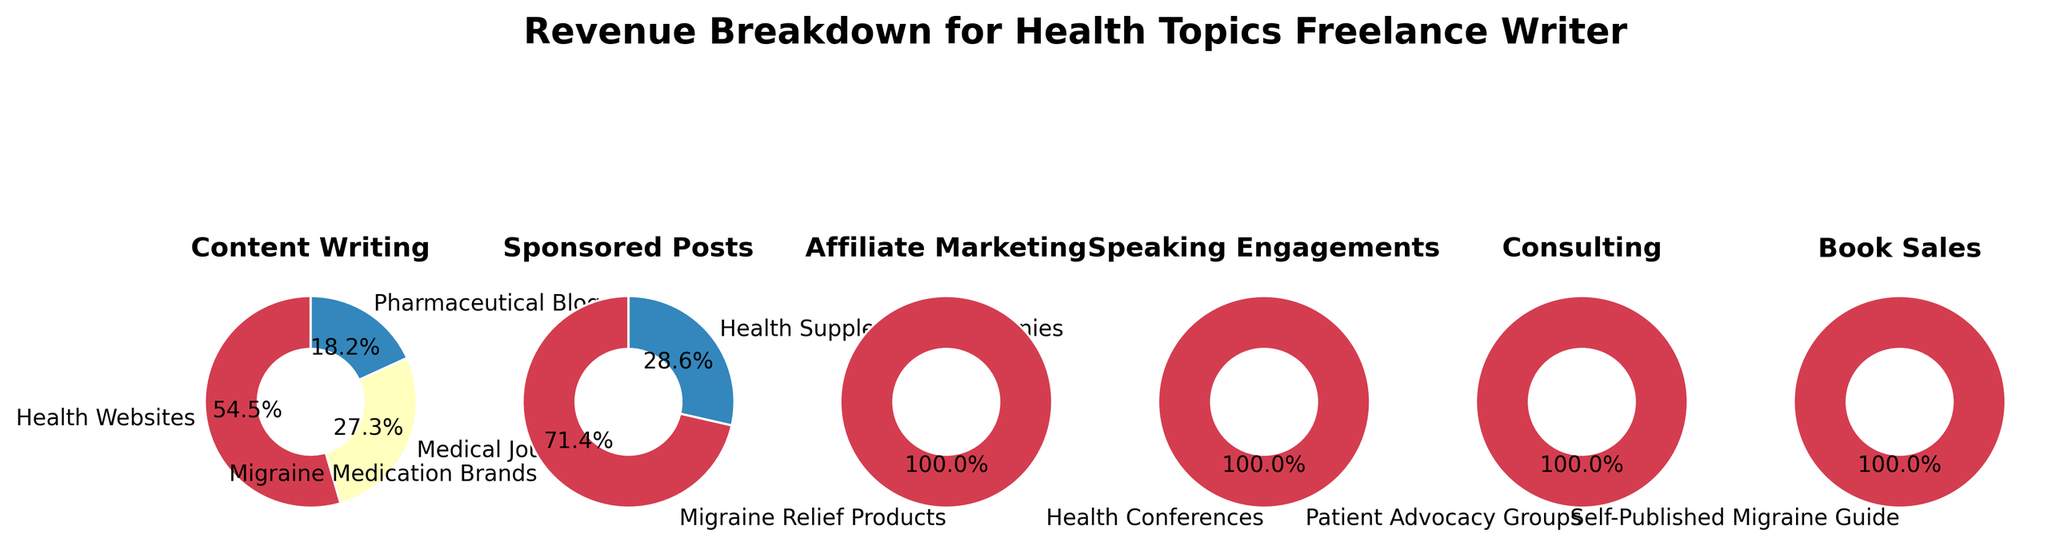What is the title of the figure? The title is displayed at the top of the figure. It reads "Revenue Breakdown for Health Topics Freelance Writer."
Answer: Revenue Breakdown for Health Topics Freelance Writer How many categories are displayed in the figure? The figure shows pie charts, each corresponding to a different category. By counting the individual pie charts, we see there are five: Content Writing, Sponsored Posts, Affiliate Marketing, Speaking Engagements, and Consulting.
Answer: Five Which category has the highest percentage for a single source? By examining the individual pie charts and the percentage labels, it is clear that Content Writing for Health Websites has 30%, which is the highest percentage for a single source.
Answer: Content Writing for Health Websites Which source contributes 20% of the revenue from Sponsored Posts? In the Sponsored Posts pie chart, Migraine Medication Brands is labeled with 20%.
Answer: Migraine Medication Brands What is the total percentage of revenue from the Speaking Engagements and Consulting categories combined? Speaking Engagements contribute 5% and Consulting contributes 3%. Adding these together gives 5% + 3% = 8%.
Answer: 8% What is the smallest revenue source in terms of percentage? Among all the sources presented in the pie charts, the Self-Published Migraine Guide within the Book Sales category has the smallest percentage at 2%.
Answer: Self-Published Migraine Guide Compare the total percentage of revenue from Content Writing and Sponsored Posts. Which category generates more revenue? By summing the percentages in each category, we have: Content Writing = 30% + 15% + 10% = 55%, Sponsored Posts = 20% + 8% = 28%. Content Writing generates more revenue.
Answer: Content Writing What is the difference in revenue percentage between Health Websites and Medical Journals within Content Writing? Health Websites contribute 30%, and Medical Journals contribute 15%. The difference is 30% - 15% = 15%.
Answer: 15% Which revenue source contributes exactly 7%? By reviewing the pie charts, Affiliate Marketing for Migraine Relief Products is labeled with 7%.
Answer: Migraine Relief Products (under Affiliate Marketing) If you combine the revenue from Health Conferences and Patient Advocacy Groups, what will be the total percentage? Health Conferences contribute 5%, and Patient Advocacy Groups contribute 3%. Adding these gives 5% + 3% = 8%.
Answer: 8% 